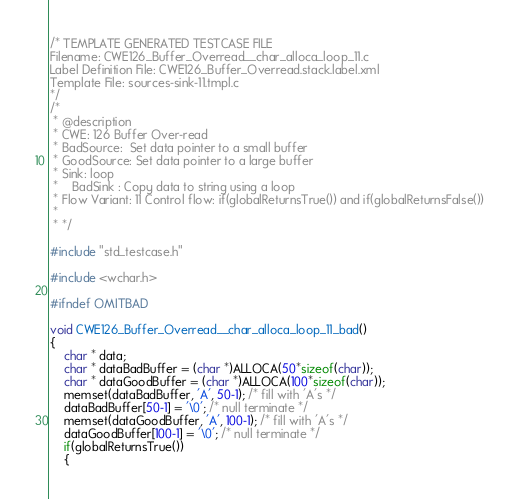<code> <loc_0><loc_0><loc_500><loc_500><_C_>/* TEMPLATE GENERATED TESTCASE FILE
Filename: CWE126_Buffer_Overread__char_alloca_loop_11.c
Label Definition File: CWE126_Buffer_Overread.stack.label.xml
Template File: sources-sink-11.tmpl.c
*/
/*
 * @description
 * CWE: 126 Buffer Over-read
 * BadSource:  Set data pointer to a small buffer
 * GoodSource: Set data pointer to a large buffer
 * Sink: loop
 *    BadSink : Copy data to string using a loop
 * Flow Variant: 11 Control flow: if(globalReturnsTrue()) and if(globalReturnsFalse())
 *
 * */

#include "std_testcase.h"

#include <wchar.h>

#ifndef OMITBAD

void CWE126_Buffer_Overread__char_alloca_loop_11_bad()
{
    char * data;
    char * dataBadBuffer = (char *)ALLOCA(50*sizeof(char));
    char * dataGoodBuffer = (char *)ALLOCA(100*sizeof(char));
    memset(dataBadBuffer, 'A', 50-1); /* fill with 'A's */
    dataBadBuffer[50-1] = '\0'; /* null terminate */
    memset(dataGoodBuffer, 'A', 100-1); /* fill with 'A's */
    dataGoodBuffer[100-1] = '\0'; /* null terminate */
    if(globalReturnsTrue())
    {</code> 